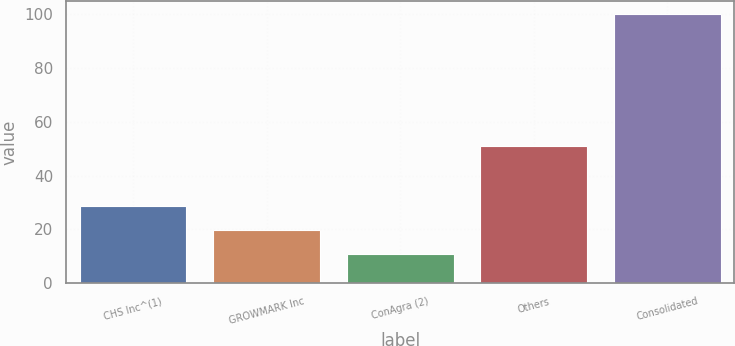Convert chart to OTSL. <chart><loc_0><loc_0><loc_500><loc_500><bar_chart><fcel>CHS Inc^(1)<fcel>GROWMARK Inc<fcel>ConAgra (2)<fcel>Others<fcel>Consolidated<nl><fcel>28.8<fcel>19.9<fcel>11<fcel>51<fcel>100<nl></chart> 